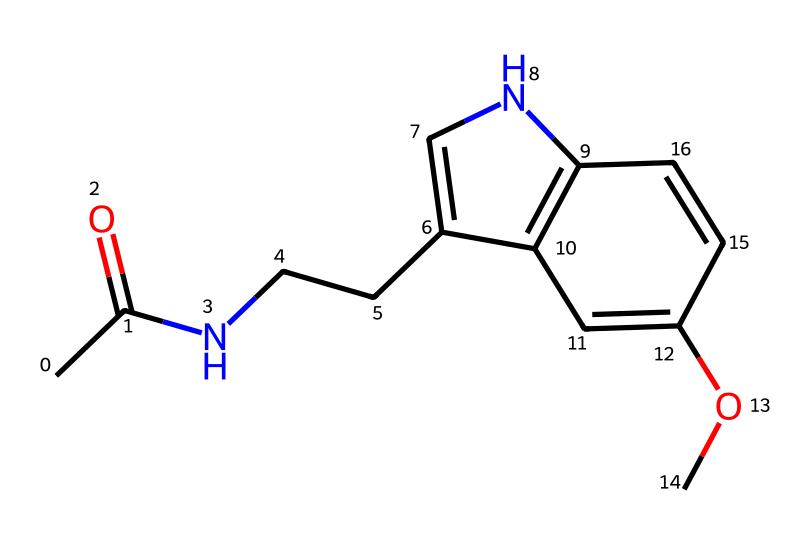What is the primary functional group present in this chemical? The structure contains a carbonyl group (C=O) represented by the ‘CC(=O)’ part. The designation ‘=O’ indicates the presence of a carbon double-bonded to an oxygen, which is characteristic of carbonyls.
Answer: carbonyl How many double bonds are in the chemical structure? By analyzing the structure, there are three double bonds denoted in the form of ‘=’ in the SMILES representation. Specifically, the double bonds are evident in the cyclic parts of the structure, in total there are three.
Answer: three What is the molecular formula of the compound represented by this SMILES? Based on the number of each type of atom represented in the SMILES, specifically counting carbon, hydrogen, nitrogen, and oxygen, we tally 13 carbons, 15 hydrogens, 2 nitrogens, and 1 oxygen, thus yielding the molecular formula C13H15N2O.
Answer: C13H15N2O Which atom is responsible for the potential photoreactivity in this chemical? The presence of the nitrogen atoms as parts of the cyclic structure indicates that they can participate in photochemical reactions, particularly involving the π-electrons of the double bonds facilitating light absorption.
Answer: nitrogen What type of cyclic structure is present in this compound? The structure contains a bicyclic system where two rings share two carbon atoms, indicated by the presence of two numbers in the SMILES such as ‘C1’ and ‘C2’. This implies a bicyclic arrangement, commonly seen in indole derivatives.
Answer: bicyclic 